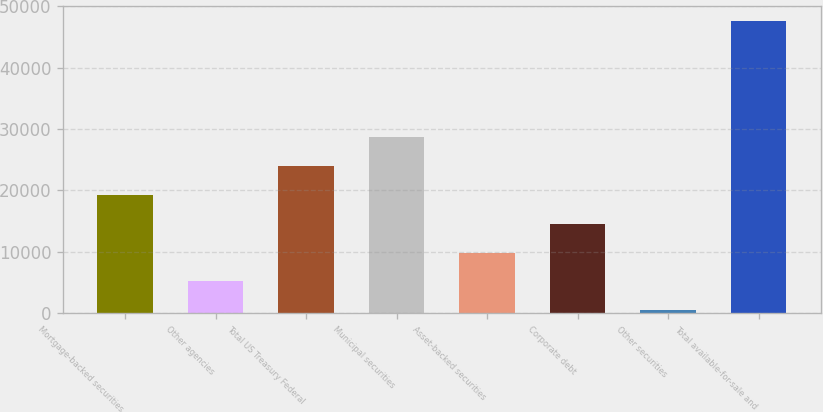Convert chart. <chart><loc_0><loc_0><loc_500><loc_500><bar_chart><fcel>Mortgage-backed securities<fcel>Other agencies<fcel>Total US Treasury Federal<fcel>Municipal securities<fcel>Asset-backed securities<fcel>Corporate debt<fcel>Other securities<fcel>Total available-for-sale and<nl><fcel>19315<fcel>5159.5<fcel>24033.5<fcel>28752<fcel>9878<fcel>14596.5<fcel>441<fcel>47626<nl></chart> 